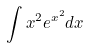<formula> <loc_0><loc_0><loc_500><loc_500>\int x ^ { 2 } e ^ { x ^ { 2 } } d x</formula> 